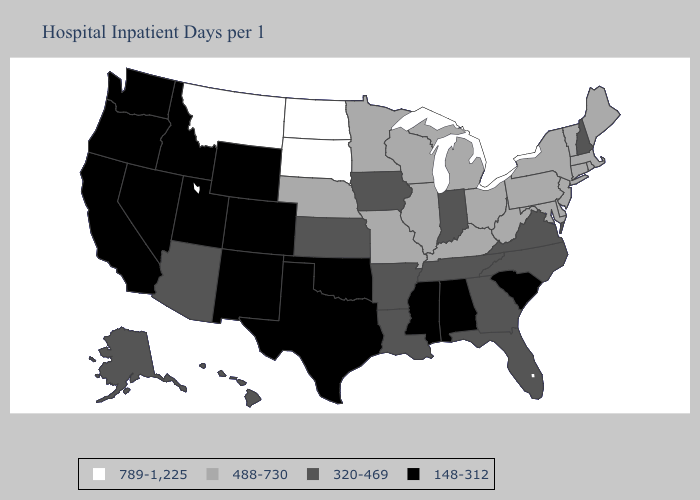Name the states that have a value in the range 789-1,225?
Quick response, please. Montana, North Dakota, South Dakota. Does Oklahoma have the highest value in the USA?
Keep it brief. No. Does Colorado have the highest value in the West?
Give a very brief answer. No. Among the states that border Missouri , does Tennessee have the highest value?
Concise answer only. No. What is the highest value in states that border Massachusetts?
Concise answer only. 488-730. What is the value of New Jersey?
Short answer required. 488-730. What is the value of Pennsylvania?
Answer briefly. 488-730. Name the states that have a value in the range 488-730?
Write a very short answer. Connecticut, Delaware, Illinois, Kentucky, Maine, Maryland, Massachusetts, Michigan, Minnesota, Missouri, Nebraska, New Jersey, New York, Ohio, Pennsylvania, Rhode Island, Vermont, West Virginia, Wisconsin. What is the value of Tennessee?
Short answer required. 320-469. Does Montana have the highest value in the West?
Give a very brief answer. Yes. What is the value of Texas?
Be succinct. 148-312. Name the states that have a value in the range 488-730?
Be succinct. Connecticut, Delaware, Illinois, Kentucky, Maine, Maryland, Massachusetts, Michigan, Minnesota, Missouri, Nebraska, New Jersey, New York, Ohio, Pennsylvania, Rhode Island, Vermont, West Virginia, Wisconsin. What is the value of Texas?
Give a very brief answer. 148-312. Name the states that have a value in the range 488-730?
Write a very short answer. Connecticut, Delaware, Illinois, Kentucky, Maine, Maryland, Massachusetts, Michigan, Minnesota, Missouri, Nebraska, New Jersey, New York, Ohio, Pennsylvania, Rhode Island, Vermont, West Virginia, Wisconsin. 